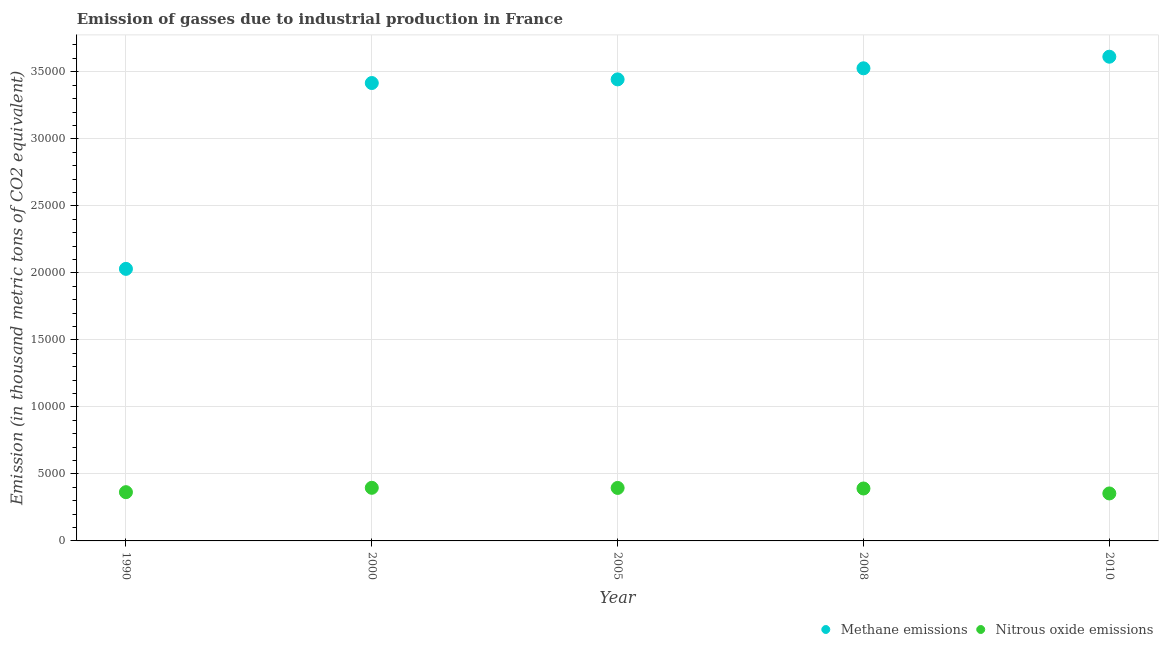Is the number of dotlines equal to the number of legend labels?
Keep it short and to the point. Yes. What is the amount of methane emissions in 1990?
Your answer should be very brief. 2.03e+04. Across all years, what is the maximum amount of methane emissions?
Make the answer very short. 3.61e+04. Across all years, what is the minimum amount of nitrous oxide emissions?
Provide a succinct answer. 3541.9. In which year was the amount of nitrous oxide emissions minimum?
Your answer should be very brief. 2010. What is the total amount of methane emissions in the graph?
Give a very brief answer. 1.60e+05. What is the difference between the amount of nitrous oxide emissions in 2005 and that in 2010?
Keep it short and to the point. 411.6. What is the difference between the amount of methane emissions in 1990 and the amount of nitrous oxide emissions in 2008?
Your response must be concise. 1.64e+04. What is the average amount of nitrous oxide emissions per year?
Your answer should be very brief. 3801.44. In the year 1990, what is the difference between the amount of nitrous oxide emissions and amount of methane emissions?
Provide a succinct answer. -1.67e+04. In how many years, is the amount of methane emissions greater than 28000 thousand metric tons?
Offer a terse response. 4. What is the ratio of the amount of methane emissions in 1990 to that in 2005?
Offer a very short reply. 0.59. Is the amount of nitrous oxide emissions in 2000 less than that in 2008?
Offer a terse response. No. What is the difference between the highest and the second highest amount of methane emissions?
Provide a short and direct response. 864.5. What is the difference between the highest and the lowest amount of methane emissions?
Your response must be concise. 1.58e+04. In how many years, is the amount of methane emissions greater than the average amount of methane emissions taken over all years?
Make the answer very short. 4. Does the amount of nitrous oxide emissions monotonically increase over the years?
Your response must be concise. No. Is the amount of methane emissions strictly less than the amount of nitrous oxide emissions over the years?
Provide a succinct answer. No. How many dotlines are there?
Your answer should be very brief. 2. Are the values on the major ticks of Y-axis written in scientific E-notation?
Your response must be concise. No. Where does the legend appear in the graph?
Provide a succinct answer. Bottom right. How many legend labels are there?
Provide a short and direct response. 2. How are the legend labels stacked?
Provide a short and direct response. Horizontal. What is the title of the graph?
Ensure brevity in your answer.  Emission of gasses due to industrial production in France. Does "Study and work" appear as one of the legend labels in the graph?
Provide a short and direct response. No. What is the label or title of the X-axis?
Provide a succinct answer. Year. What is the label or title of the Y-axis?
Provide a succinct answer. Emission (in thousand metric tons of CO2 equivalent). What is the Emission (in thousand metric tons of CO2 equivalent) in Methane emissions in 1990?
Your answer should be compact. 2.03e+04. What is the Emission (in thousand metric tons of CO2 equivalent) in Nitrous oxide emissions in 1990?
Offer a very short reply. 3637.1. What is the Emission (in thousand metric tons of CO2 equivalent) of Methane emissions in 2000?
Give a very brief answer. 3.42e+04. What is the Emission (in thousand metric tons of CO2 equivalent) in Nitrous oxide emissions in 2000?
Provide a short and direct response. 3963. What is the Emission (in thousand metric tons of CO2 equivalent) in Methane emissions in 2005?
Ensure brevity in your answer.  3.44e+04. What is the Emission (in thousand metric tons of CO2 equivalent) in Nitrous oxide emissions in 2005?
Provide a short and direct response. 3953.5. What is the Emission (in thousand metric tons of CO2 equivalent) in Methane emissions in 2008?
Your response must be concise. 3.53e+04. What is the Emission (in thousand metric tons of CO2 equivalent) in Nitrous oxide emissions in 2008?
Offer a very short reply. 3911.7. What is the Emission (in thousand metric tons of CO2 equivalent) of Methane emissions in 2010?
Keep it short and to the point. 3.61e+04. What is the Emission (in thousand metric tons of CO2 equivalent) in Nitrous oxide emissions in 2010?
Your response must be concise. 3541.9. Across all years, what is the maximum Emission (in thousand metric tons of CO2 equivalent) of Methane emissions?
Ensure brevity in your answer.  3.61e+04. Across all years, what is the maximum Emission (in thousand metric tons of CO2 equivalent) in Nitrous oxide emissions?
Make the answer very short. 3963. Across all years, what is the minimum Emission (in thousand metric tons of CO2 equivalent) in Methane emissions?
Offer a very short reply. 2.03e+04. Across all years, what is the minimum Emission (in thousand metric tons of CO2 equivalent) of Nitrous oxide emissions?
Your answer should be very brief. 3541.9. What is the total Emission (in thousand metric tons of CO2 equivalent) in Methane emissions in the graph?
Your response must be concise. 1.60e+05. What is the total Emission (in thousand metric tons of CO2 equivalent) of Nitrous oxide emissions in the graph?
Provide a short and direct response. 1.90e+04. What is the difference between the Emission (in thousand metric tons of CO2 equivalent) in Methane emissions in 1990 and that in 2000?
Your answer should be compact. -1.39e+04. What is the difference between the Emission (in thousand metric tons of CO2 equivalent) of Nitrous oxide emissions in 1990 and that in 2000?
Your answer should be very brief. -325.9. What is the difference between the Emission (in thousand metric tons of CO2 equivalent) in Methane emissions in 1990 and that in 2005?
Your answer should be compact. -1.41e+04. What is the difference between the Emission (in thousand metric tons of CO2 equivalent) of Nitrous oxide emissions in 1990 and that in 2005?
Your response must be concise. -316.4. What is the difference between the Emission (in thousand metric tons of CO2 equivalent) in Methane emissions in 1990 and that in 2008?
Offer a terse response. -1.50e+04. What is the difference between the Emission (in thousand metric tons of CO2 equivalent) of Nitrous oxide emissions in 1990 and that in 2008?
Offer a terse response. -274.6. What is the difference between the Emission (in thousand metric tons of CO2 equivalent) in Methane emissions in 1990 and that in 2010?
Give a very brief answer. -1.58e+04. What is the difference between the Emission (in thousand metric tons of CO2 equivalent) in Nitrous oxide emissions in 1990 and that in 2010?
Your answer should be very brief. 95.2. What is the difference between the Emission (in thousand metric tons of CO2 equivalent) of Methane emissions in 2000 and that in 2005?
Provide a succinct answer. -272.3. What is the difference between the Emission (in thousand metric tons of CO2 equivalent) of Nitrous oxide emissions in 2000 and that in 2005?
Keep it short and to the point. 9.5. What is the difference between the Emission (in thousand metric tons of CO2 equivalent) of Methane emissions in 2000 and that in 2008?
Make the answer very short. -1098.9. What is the difference between the Emission (in thousand metric tons of CO2 equivalent) of Nitrous oxide emissions in 2000 and that in 2008?
Provide a short and direct response. 51.3. What is the difference between the Emission (in thousand metric tons of CO2 equivalent) in Methane emissions in 2000 and that in 2010?
Provide a succinct answer. -1963.4. What is the difference between the Emission (in thousand metric tons of CO2 equivalent) in Nitrous oxide emissions in 2000 and that in 2010?
Your answer should be very brief. 421.1. What is the difference between the Emission (in thousand metric tons of CO2 equivalent) in Methane emissions in 2005 and that in 2008?
Your response must be concise. -826.6. What is the difference between the Emission (in thousand metric tons of CO2 equivalent) of Nitrous oxide emissions in 2005 and that in 2008?
Your answer should be compact. 41.8. What is the difference between the Emission (in thousand metric tons of CO2 equivalent) of Methane emissions in 2005 and that in 2010?
Give a very brief answer. -1691.1. What is the difference between the Emission (in thousand metric tons of CO2 equivalent) of Nitrous oxide emissions in 2005 and that in 2010?
Offer a very short reply. 411.6. What is the difference between the Emission (in thousand metric tons of CO2 equivalent) in Methane emissions in 2008 and that in 2010?
Provide a succinct answer. -864.5. What is the difference between the Emission (in thousand metric tons of CO2 equivalent) of Nitrous oxide emissions in 2008 and that in 2010?
Offer a very short reply. 369.8. What is the difference between the Emission (in thousand metric tons of CO2 equivalent) in Methane emissions in 1990 and the Emission (in thousand metric tons of CO2 equivalent) in Nitrous oxide emissions in 2000?
Keep it short and to the point. 1.63e+04. What is the difference between the Emission (in thousand metric tons of CO2 equivalent) of Methane emissions in 1990 and the Emission (in thousand metric tons of CO2 equivalent) of Nitrous oxide emissions in 2005?
Provide a short and direct response. 1.63e+04. What is the difference between the Emission (in thousand metric tons of CO2 equivalent) in Methane emissions in 1990 and the Emission (in thousand metric tons of CO2 equivalent) in Nitrous oxide emissions in 2008?
Offer a very short reply. 1.64e+04. What is the difference between the Emission (in thousand metric tons of CO2 equivalent) in Methane emissions in 1990 and the Emission (in thousand metric tons of CO2 equivalent) in Nitrous oxide emissions in 2010?
Your answer should be compact. 1.68e+04. What is the difference between the Emission (in thousand metric tons of CO2 equivalent) in Methane emissions in 2000 and the Emission (in thousand metric tons of CO2 equivalent) in Nitrous oxide emissions in 2005?
Make the answer very short. 3.02e+04. What is the difference between the Emission (in thousand metric tons of CO2 equivalent) in Methane emissions in 2000 and the Emission (in thousand metric tons of CO2 equivalent) in Nitrous oxide emissions in 2008?
Offer a very short reply. 3.03e+04. What is the difference between the Emission (in thousand metric tons of CO2 equivalent) of Methane emissions in 2000 and the Emission (in thousand metric tons of CO2 equivalent) of Nitrous oxide emissions in 2010?
Provide a short and direct response. 3.06e+04. What is the difference between the Emission (in thousand metric tons of CO2 equivalent) of Methane emissions in 2005 and the Emission (in thousand metric tons of CO2 equivalent) of Nitrous oxide emissions in 2008?
Your answer should be very brief. 3.05e+04. What is the difference between the Emission (in thousand metric tons of CO2 equivalent) in Methane emissions in 2005 and the Emission (in thousand metric tons of CO2 equivalent) in Nitrous oxide emissions in 2010?
Provide a short and direct response. 3.09e+04. What is the difference between the Emission (in thousand metric tons of CO2 equivalent) in Methane emissions in 2008 and the Emission (in thousand metric tons of CO2 equivalent) in Nitrous oxide emissions in 2010?
Offer a terse response. 3.17e+04. What is the average Emission (in thousand metric tons of CO2 equivalent) in Methane emissions per year?
Provide a succinct answer. 3.21e+04. What is the average Emission (in thousand metric tons of CO2 equivalent) of Nitrous oxide emissions per year?
Make the answer very short. 3801.44. In the year 1990, what is the difference between the Emission (in thousand metric tons of CO2 equivalent) in Methane emissions and Emission (in thousand metric tons of CO2 equivalent) in Nitrous oxide emissions?
Your answer should be compact. 1.67e+04. In the year 2000, what is the difference between the Emission (in thousand metric tons of CO2 equivalent) in Methane emissions and Emission (in thousand metric tons of CO2 equivalent) in Nitrous oxide emissions?
Offer a very short reply. 3.02e+04. In the year 2005, what is the difference between the Emission (in thousand metric tons of CO2 equivalent) of Methane emissions and Emission (in thousand metric tons of CO2 equivalent) of Nitrous oxide emissions?
Provide a succinct answer. 3.05e+04. In the year 2008, what is the difference between the Emission (in thousand metric tons of CO2 equivalent) of Methane emissions and Emission (in thousand metric tons of CO2 equivalent) of Nitrous oxide emissions?
Your response must be concise. 3.13e+04. In the year 2010, what is the difference between the Emission (in thousand metric tons of CO2 equivalent) in Methane emissions and Emission (in thousand metric tons of CO2 equivalent) in Nitrous oxide emissions?
Make the answer very short. 3.26e+04. What is the ratio of the Emission (in thousand metric tons of CO2 equivalent) in Methane emissions in 1990 to that in 2000?
Keep it short and to the point. 0.59. What is the ratio of the Emission (in thousand metric tons of CO2 equivalent) of Nitrous oxide emissions in 1990 to that in 2000?
Provide a succinct answer. 0.92. What is the ratio of the Emission (in thousand metric tons of CO2 equivalent) of Methane emissions in 1990 to that in 2005?
Provide a short and direct response. 0.59. What is the ratio of the Emission (in thousand metric tons of CO2 equivalent) in Methane emissions in 1990 to that in 2008?
Ensure brevity in your answer.  0.58. What is the ratio of the Emission (in thousand metric tons of CO2 equivalent) of Nitrous oxide emissions in 1990 to that in 2008?
Make the answer very short. 0.93. What is the ratio of the Emission (in thousand metric tons of CO2 equivalent) in Methane emissions in 1990 to that in 2010?
Your response must be concise. 0.56. What is the ratio of the Emission (in thousand metric tons of CO2 equivalent) of Nitrous oxide emissions in 1990 to that in 2010?
Your answer should be very brief. 1.03. What is the ratio of the Emission (in thousand metric tons of CO2 equivalent) in Methane emissions in 2000 to that in 2005?
Provide a short and direct response. 0.99. What is the ratio of the Emission (in thousand metric tons of CO2 equivalent) in Methane emissions in 2000 to that in 2008?
Provide a short and direct response. 0.97. What is the ratio of the Emission (in thousand metric tons of CO2 equivalent) in Nitrous oxide emissions in 2000 to that in 2008?
Your answer should be compact. 1.01. What is the ratio of the Emission (in thousand metric tons of CO2 equivalent) of Methane emissions in 2000 to that in 2010?
Keep it short and to the point. 0.95. What is the ratio of the Emission (in thousand metric tons of CO2 equivalent) of Nitrous oxide emissions in 2000 to that in 2010?
Make the answer very short. 1.12. What is the ratio of the Emission (in thousand metric tons of CO2 equivalent) in Methane emissions in 2005 to that in 2008?
Provide a short and direct response. 0.98. What is the ratio of the Emission (in thousand metric tons of CO2 equivalent) in Nitrous oxide emissions in 2005 to that in 2008?
Your answer should be very brief. 1.01. What is the ratio of the Emission (in thousand metric tons of CO2 equivalent) of Methane emissions in 2005 to that in 2010?
Keep it short and to the point. 0.95. What is the ratio of the Emission (in thousand metric tons of CO2 equivalent) of Nitrous oxide emissions in 2005 to that in 2010?
Provide a succinct answer. 1.12. What is the ratio of the Emission (in thousand metric tons of CO2 equivalent) in Methane emissions in 2008 to that in 2010?
Ensure brevity in your answer.  0.98. What is the ratio of the Emission (in thousand metric tons of CO2 equivalent) of Nitrous oxide emissions in 2008 to that in 2010?
Keep it short and to the point. 1.1. What is the difference between the highest and the second highest Emission (in thousand metric tons of CO2 equivalent) of Methane emissions?
Make the answer very short. 864.5. What is the difference between the highest and the second highest Emission (in thousand metric tons of CO2 equivalent) in Nitrous oxide emissions?
Offer a very short reply. 9.5. What is the difference between the highest and the lowest Emission (in thousand metric tons of CO2 equivalent) in Methane emissions?
Your response must be concise. 1.58e+04. What is the difference between the highest and the lowest Emission (in thousand metric tons of CO2 equivalent) of Nitrous oxide emissions?
Keep it short and to the point. 421.1. 